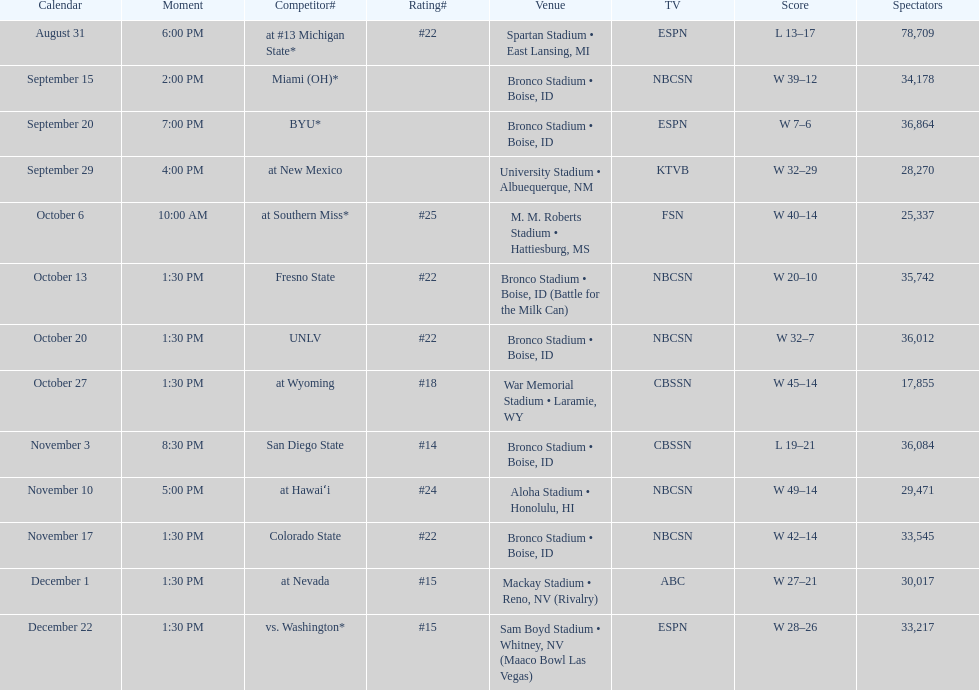What is the total number of games played at bronco stadium? 6. 